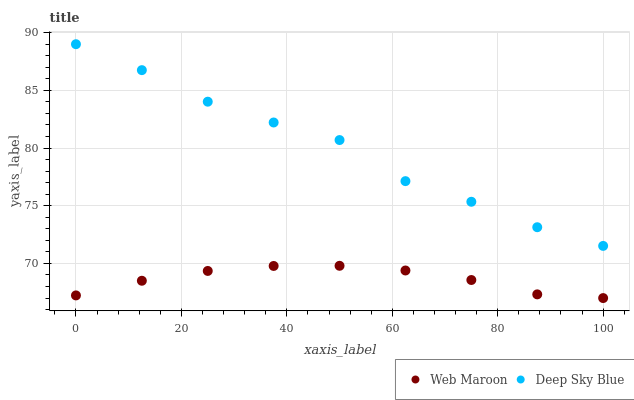Does Web Maroon have the minimum area under the curve?
Answer yes or no. Yes. Does Deep Sky Blue have the maximum area under the curve?
Answer yes or no. Yes. Does Deep Sky Blue have the minimum area under the curve?
Answer yes or no. No. Is Web Maroon the smoothest?
Answer yes or no. Yes. Is Deep Sky Blue the roughest?
Answer yes or no. Yes. Is Deep Sky Blue the smoothest?
Answer yes or no. No. Does Web Maroon have the lowest value?
Answer yes or no. Yes. Does Deep Sky Blue have the lowest value?
Answer yes or no. No. Does Deep Sky Blue have the highest value?
Answer yes or no. Yes. Is Web Maroon less than Deep Sky Blue?
Answer yes or no. Yes. Is Deep Sky Blue greater than Web Maroon?
Answer yes or no. Yes. Does Web Maroon intersect Deep Sky Blue?
Answer yes or no. No. 